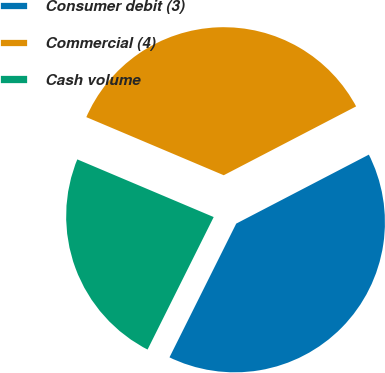<chart> <loc_0><loc_0><loc_500><loc_500><pie_chart><fcel>Consumer debit (3)<fcel>Commercial (4)<fcel>Cash volume<nl><fcel>40.0%<fcel>36.0%<fcel>24.0%<nl></chart> 